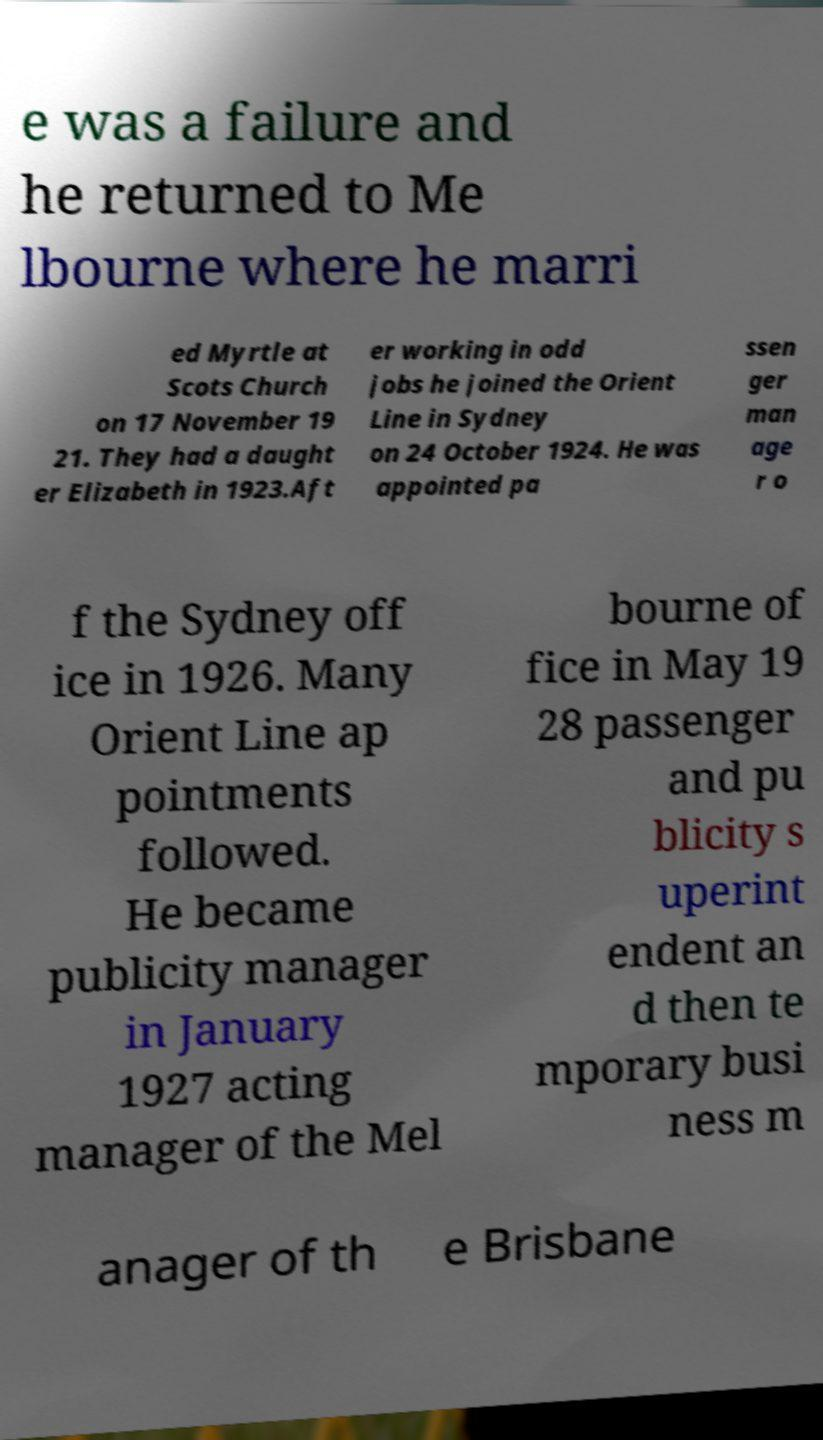What messages or text are displayed in this image? I need them in a readable, typed format. e was a failure and he returned to Me lbourne where he marri ed Myrtle at Scots Church on 17 November 19 21. They had a daught er Elizabeth in 1923.Aft er working in odd jobs he joined the Orient Line in Sydney on 24 October 1924. He was appointed pa ssen ger man age r o f the Sydney off ice in 1926. Many Orient Line ap pointments followed. He became publicity manager in January 1927 acting manager of the Mel bourne of fice in May 19 28 passenger and pu blicity s uperint endent an d then te mporary busi ness m anager of th e Brisbane 